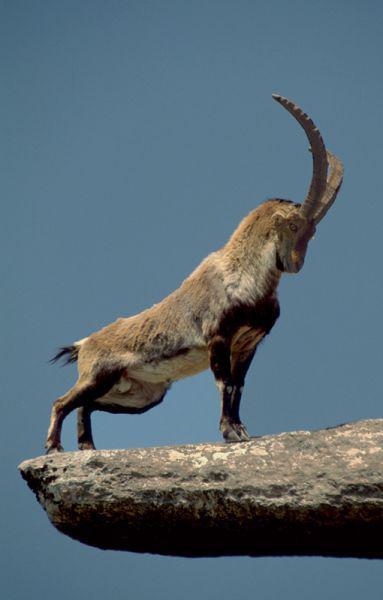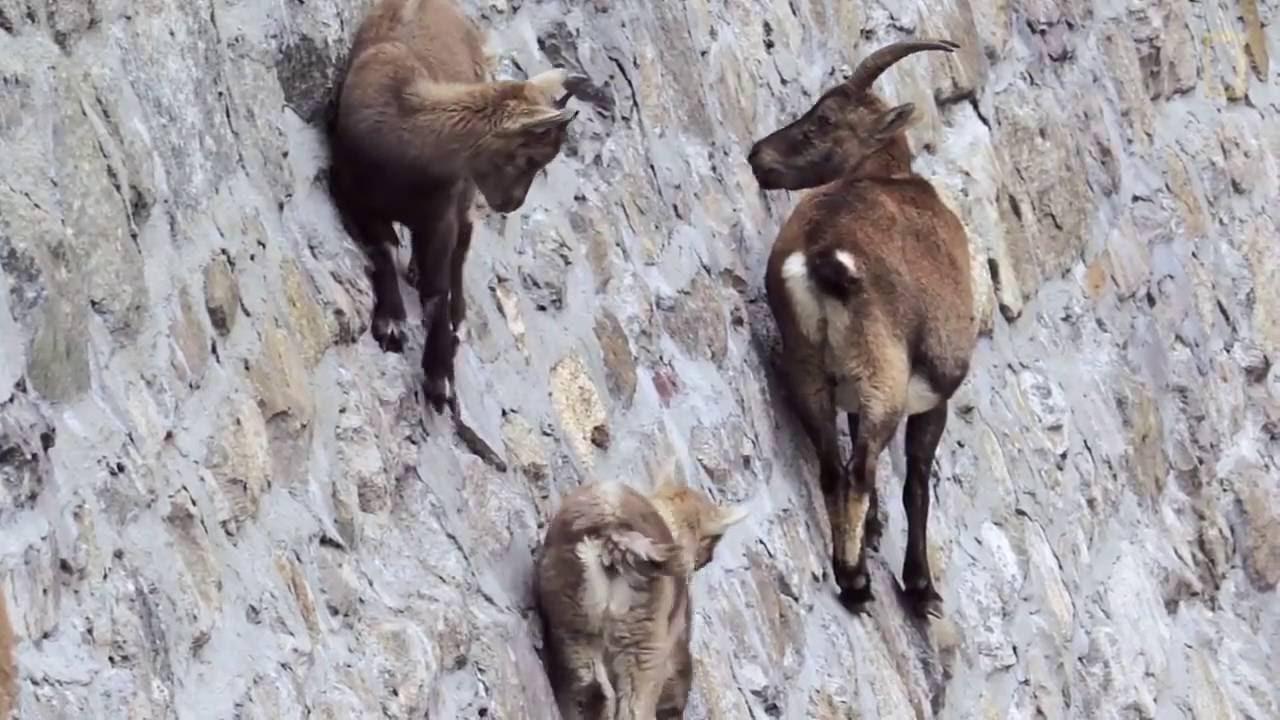The first image is the image on the left, the second image is the image on the right. Evaluate the accuracy of this statement regarding the images: "In one image the tail of the mountain goat is visible.". Is it true? Answer yes or no. Yes. The first image is the image on the left, the second image is the image on the right. For the images shown, is this caption "In one of the images of each pair two of the animals are looking at each other." true? Answer yes or no. Yes. 